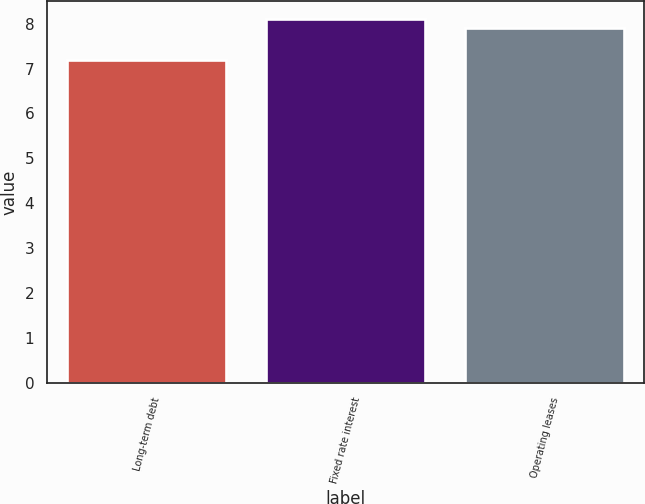Convert chart. <chart><loc_0><loc_0><loc_500><loc_500><bar_chart><fcel>Long-term debt<fcel>Fixed rate interest<fcel>Operating leases<nl><fcel>7.2<fcel>8.1<fcel>7.9<nl></chart> 